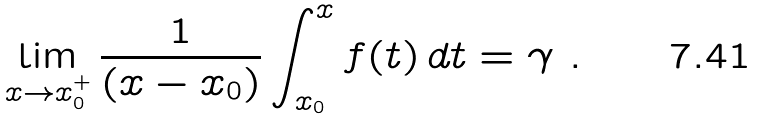Convert formula to latex. <formula><loc_0><loc_0><loc_500><loc_500>\lim _ { x \to x ^ { + } _ { 0 } } \frac { 1 } { ( x - x _ { 0 } ) } \int _ { x _ { 0 } } ^ { x } f ( t ) \, d t = \gamma \ .</formula> 